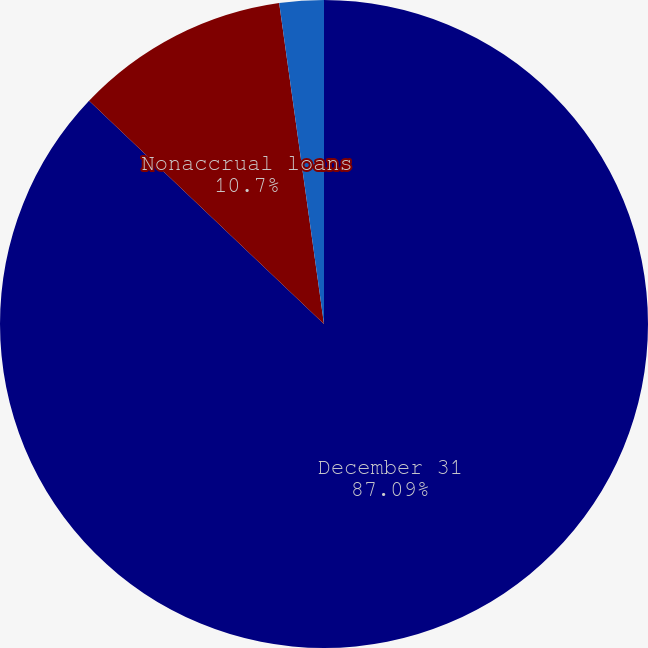Convert chart to OTSL. <chart><loc_0><loc_0><loc_500><loc_500><pie_chart><fcel>December 31<fcel>Nonaccrual loans<fcel>Average nonaccrual loans<nl><fcel>87.09%<fcel>10.7%<fcel>2.21%<nl></chart> 